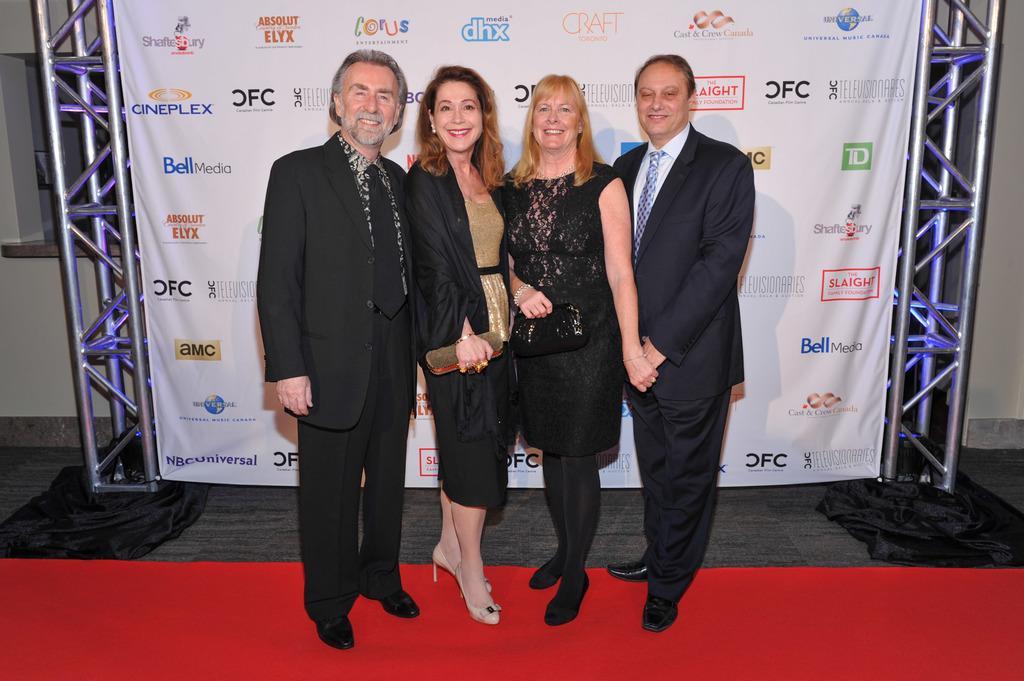In one or two sentences, can you explain what this image depicts? In this picture I can see few people are standing on the red carpet, behind we can see a banner to the iron poles. 